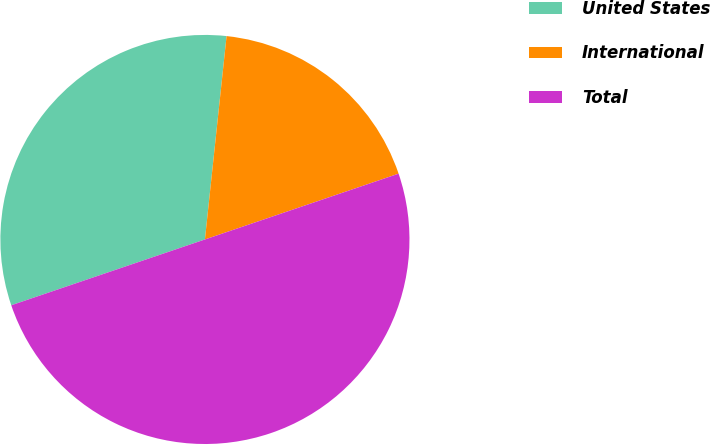<chart> <loc_0><loc_0><loc_500><loc_500><pie_chart><fcel>United States<fcel>International<fcel>Total<nl><fcel>31.9%<fcel>18.1%<fcel>50.0%<nl></chart> 